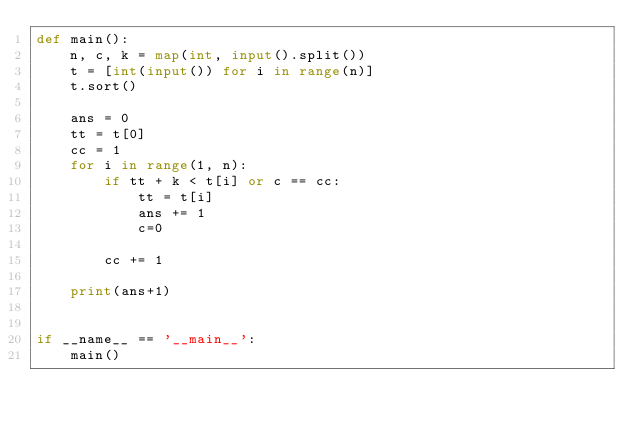<code> <loc_0><loc_0><loc_500><loc_500><_Python_>def main():
    n, c, k = map(int, input().split())
    t = [int(input()) for i in range(n)]
    t.sort()

    ans = 0
    tt = t[0]
    cc = 1
    for i in range(1, n):
        if tt + k < t[i] or c == cc:
            tt = t[i]
            ans += 1
            c=0

        cc += 1

    print(ans+1)


if __name__ == '__main__':
    main()</code> 